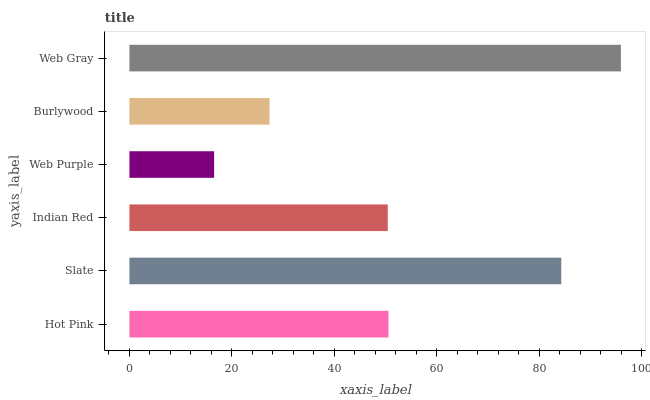Is Web Purple the minimum?
Answer yes or no. Yes. Is Web Gray the maximum?
Answer yes or no. Yes. Is Slate the minimum?
Answer yes or no. No. Is Slate the maximum?
Answer yes or no. No. Is Slate greater than Hot Pink?
Answer yes or no. Yes. Is Hot Pink less than Slate?
Answer yes or no. Yes. Is Hot Pink greater than Slate?
Answer yes or no. No. Is Slate less than Hot Pink?
Answer yes or no. No. Is Hot Pink the high median?
Answer yes or no. Yes. Is Indian Red the low median?
Answer yes or no. Yes. Is Web Purple the high median?
Answer yes or no. No. Is Hot Pink the low median?
Answer yes or no. No. 